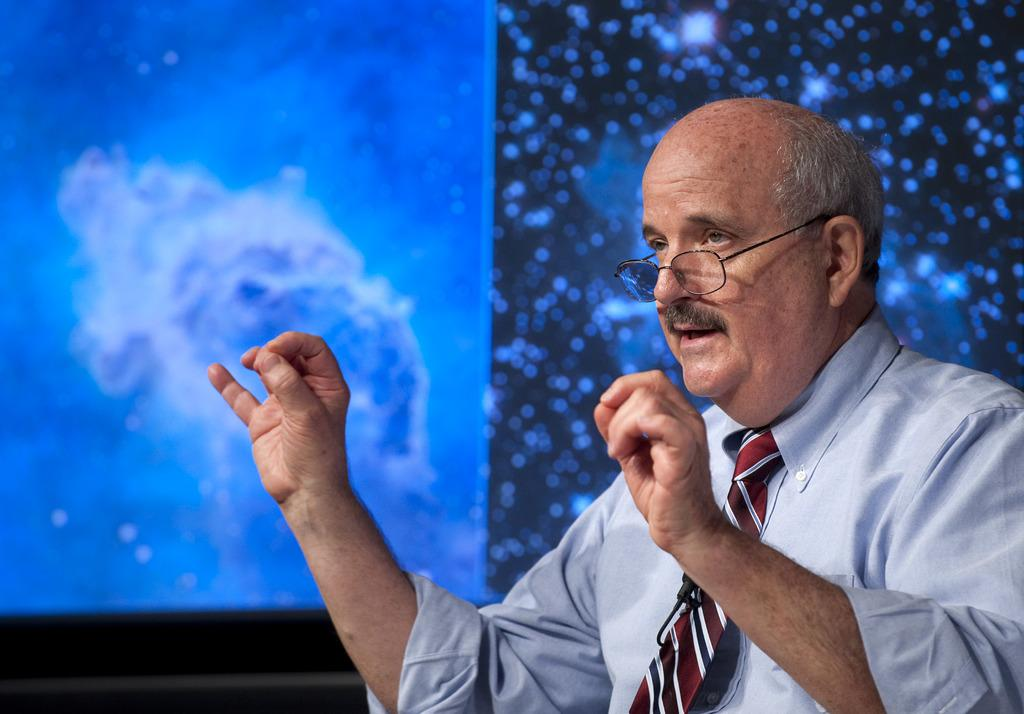What is the main subject in the foreground of the image? There is a person in the foreground of the image. What can be seen in the background of the image? There is a screen in the background of the image. What type of blade is being used by the person in the image? There is no blade visible in the image; the person is not using any tool or object. 